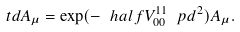Convert formula to latex. <formula><loc_0><loc_0><loc_500><loc_500>\ t d A _ { \mu } = \exp ( - \ h a l f V ^ { 1 1 } _ { 0 0 } \ p d ^ { 2 } ) A _ { \mu } .</formula> 